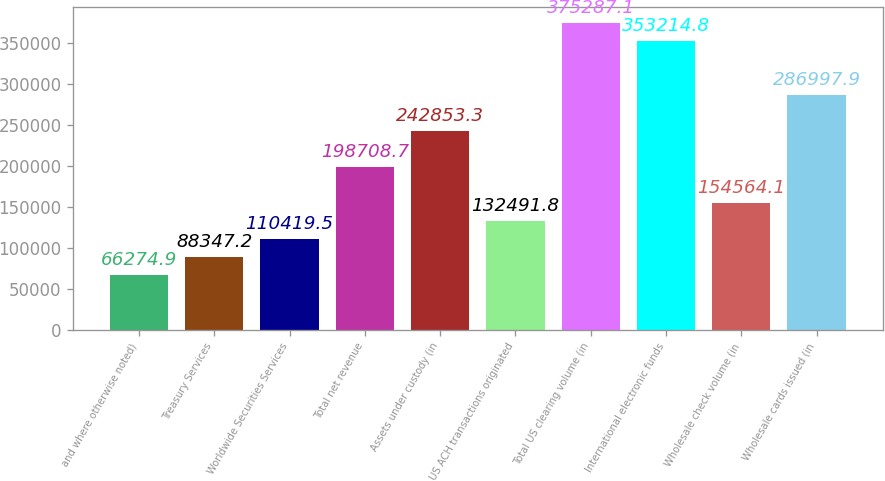Convert chart to OTSL. <chart><loc_0><loc_0><loc_500><loc_500><bar_chart><fcel>and where otherwise noted)<fcel>Treasury Services<fcel>Worldwide Securities Services<fcel>Total net revenue<fcel>Assets under custody (in<fcel>US ACH transactions originated<fcel>Total US clearing volume (in<fcel>International electronic funds<fcel>Wholesale check volume (in<fcel>Wholesale cards issued (in<nl><fcel>66274.9<fcel>88347.2<fcel>110420<fcel>198709<fcel>242853<fcel>132492<fcel>375287<fcel>353215<fcel>154564<fcel>286998<nl></chart> 